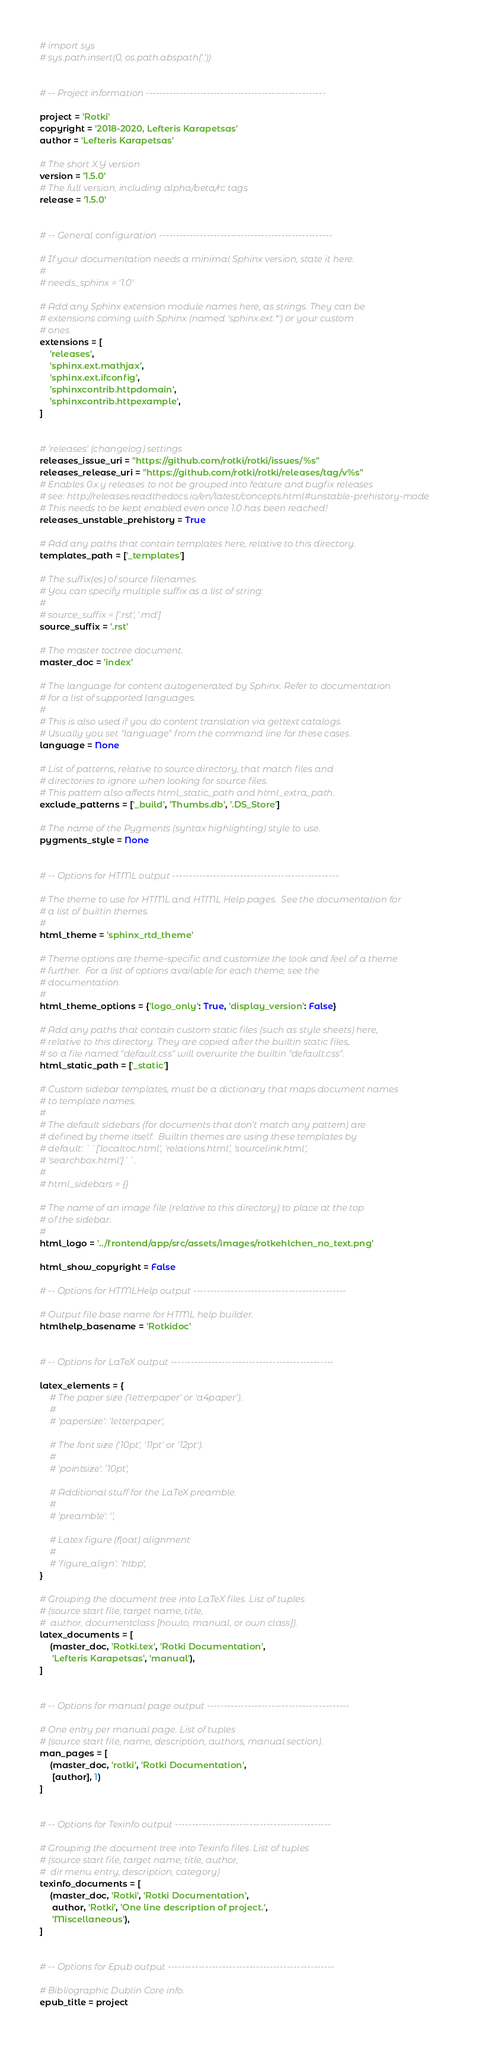Convert code to text. <code><loc_0><loc_0><loc_500><loc_500><_Python_># import sys
# sys.path.insert(0, os.path.abspath('.'))


# -- Project information -----------------------------------------------------

project = 'Rotki'
copyright = '2018-2020, Lefteris Karapetsas'
author = 'Lefteris Karapetsas'

# The short X.Y version
version = '1.5.0'
# The full version, including alpha/beta/rc tags
release = '1.5.0'


# -- General configuration ---------------------------------------------------

# If your documentation needs a minimal Sphinx version, state it here.
#
# needs_sphinx = '1.0'

# Add any Sphinx extension module names here, as strings. They can be
# extensions coming with Sphinx (named 'sphinx.ext.*') or your custom
# ones.
extensions = [
    'releases',
    'sphinx.ext.mathjax',
    'sphinx.ext.ifconfig',
    'sphinxcontrib.httpdomain',
    'sphinxcontrib.httpexample',
]


# 'releases' (changelog) settings
releases_issue_uri = "https://github.com/rotki/rotki/issues/%s"
releases_release_uri = "https://github.com/rotki/rotki/releases/tag/v%s"
# Enables 0.x.y releases to not be grouped into feature and bugfix releases
# see: http://releases.readthedocs.io/en/latest/concepts.html#unstable-prehistory-mode
# This needs to be kept enabled even once 1.0 has been reached!
releases_unstable_prehistory = True

# Add any paths that contain templates here, relative to this directory.
templates_path = ['_templates']

# The suffix(es) of source filenames.
# You can specify multiple suffix as a list of string:
#
# source_suffix = ['.rst', '.md']
source_suffix = '.rst'

# The master toctree document.
master_doc = 'index'

# The language for content autogenerated by Sphinx. Refer to documentation
# for a list of supported languages.
#
# This is also used if you do content translation via gettext catalogs.
# Usually you set "language" from the command line for these cases.
language = None

# List of patterns, relative to source directory, that match files and
# directories to ignore when looking for source files.
# This pattern also affects html_static_path and html_extra_path.
exclude_patterns = ['_build', 'Thumbs.db', '.DS_Store']

# The name of the Pygments (syntax highlighting) style to use.
pygments_style = None


# -- Options for HTML output -------------------------------------------------

# The theme to use for HTML and HTML Help pages.  See the documentation for
# a list of builtin themes.
#
html_theme = 'sphinx_rtd_theme'

# Theme options are theme-specific and customize the look and feel of a theme
# further.  For a list of options available for each theme, see the
# documentation.
#
html_theme_options = {'logo_only': True, 'display_version': False}

# Add any paths that contain custom static files (such as style sheets) here,
# relative to this directory. They are copied after the builtin static files,
# so a file named "default.css" will overwrite the builtin "default.css".
html_static_path = ['_static']

# Custom sidebar templates, must be a dictionary that maps document names
# to template names.
#
# The default sidebars (for documents that don't match any pattern) are
# defined by theme itself.  Builtin themes are using these templates by
# default: ``['localtoc.html', 'relations.html', 'sourcelink.html',
# 'searchbox.html']``.
#
# html_sidebars = {}

# The name of an image file (relative to this directory) to place at the top
# of the sidebar.
#
html_logo = '../frontend/app/src/assets/images/rotkehlchen_no_text.png'

html_show_copyright = False

# -- Options for HTMLHelp output ---------------------------------------------

# Output file base name for HTML help builder.
htmlhelp_basename = 'Rotkidoc'


# -- Options for LaTeX output ------------------------------------------------

latex_elements = {
    # The paper size ('letterpaper' or 'a4paper').
    #
    # 'papersize': 'letterpaper',

    # The font size ('10pt', '11pt' or '12pt').
    #
    # 'pointsize': '10pt',

    # Additional stuff for the LaTeX preamble.
    #
    # 'preamble': '',

    # Latex figure (float) alignment
    #
    # 'figure_align': 'htbp',
}

# Grouping the document tree into LaTeX files. List of tuples
# (source start file, target name, title,
#  author, documentclass [howto, manual, or own class]).
latex_documents = [
    (master_doc, 'Rotki.tex', 'Rotki Documentation',
     'Lefteris Karapetsas', 'manual'),
]


# -- Options for manual page output ------------------------------------------

# One entry per manual page. List of tuples
# (source start file, name, description, authors, manual section).
man_pages = [
    (master_doc, 'rotki', 'Rotki Documentation',
     [author], 1)
]


# -- Options for Texinfo output ----------------------------------------------

# Grouping the document tree into Texinfo files. List of tuples
# (source start file, target name, title, author,
#  dir menu entry, description, category)
texinfo_documents = [
    (master_doc, 'Rotki', 'Rotki Documentation',
     author, 'Rotki', 'One line description of project.',
     'Miscellaneous'),
]


# -- Options for Epub output -------------------------------------------------

# Bibliographic Dublin Core info.
epub_title = project
</code> 